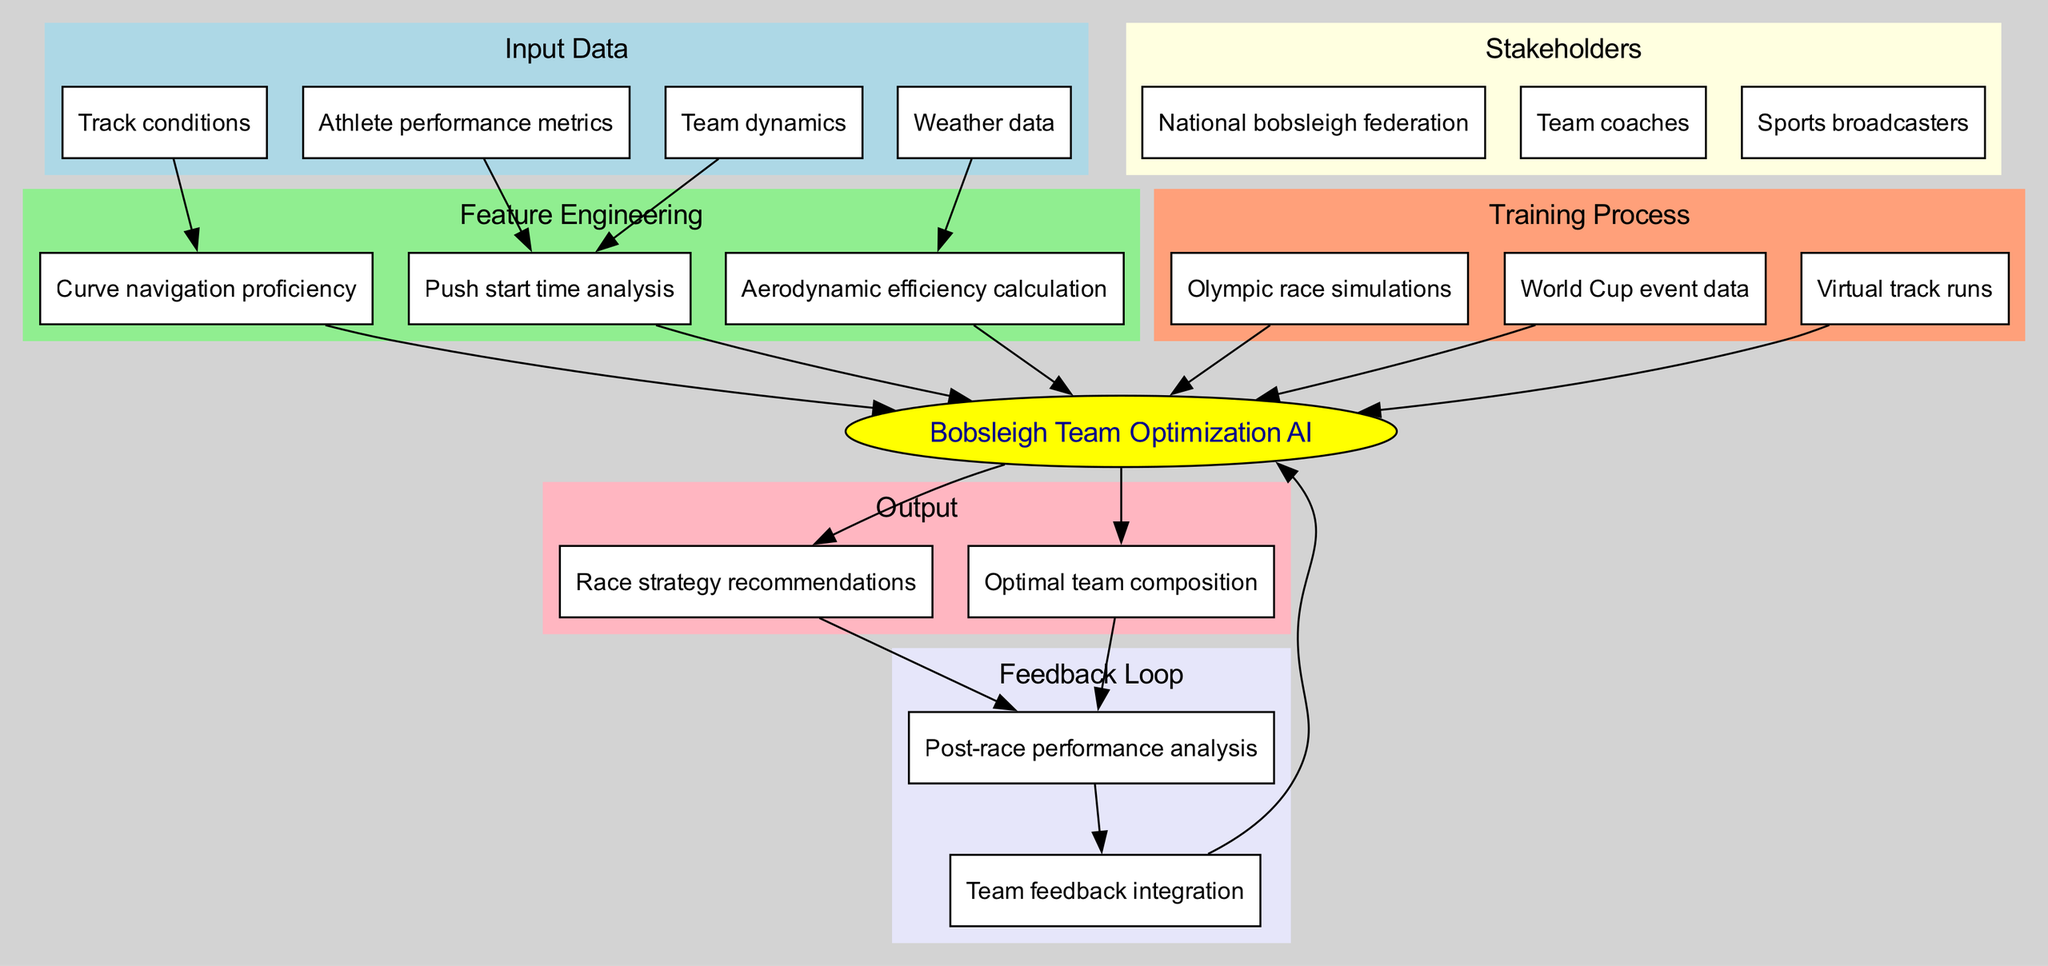What are the input data types in this diagram? The diagram lists four specific input data types: "Athlete performance metrics," "Track conditions," "Weather data," and "Team dynamics." These are located in the "Input Data" section at the top of the diagram.
Answer: Athlete performance metrics, Track conditions, Weather data, Team dynamics How many edges are connected to the "Bobsleigh Team Optimization AI" node? The "Bobsleigh Team Optimization AI" node has four edges connected to it: one from each of the "Feature Engineering" and "Training Process" sections, and two from the output nodes. This shows how inputs and processes directly link to the model's output.
Answer: Four Which feedback loop activity comes after the "Post-race performance analysis"? Following "Post-race performance analysis," the next activity in the feedback loop is "Team feedback integration." This can be traced by moving down from the analysis node.
Answer: Team feedback integration What are the output components of the model? The output components listed in the diagram are "Optimal team composition" and "Race strategy recommendations." Both these outputs are derived from the Bobsleigh model and are found in the "Output" section.
Answer: Optimal team composition, Race strategy recommendations How does "Weather data" influence the model? "Weather data" impacts the model by feeding into the "Aerodynamic efficiency calculation" feature engineering process, indicating that weather conditions are a factor in optimizing performance metrics for bobsleigh.
Answer: Aerodynamic efficiency calculation What is the significance of the "Training Process" section? The "Training Process" section provides essential simulation techniques and historical data used to train the model: "Olympic race simulations," "World Cup event data," and "Virtual track runs." This shows the methods used to refine the model's predictions and strategy.
Answer: Olympic race simulations, World Cup event data, Virtual track runs Who are the stakeholders identified in the diagram? The stakeholders identified are "National bobsleigh federation," "Team coaches," and "Sports broadcasters." These roles indicate the involved parties who utilize or influence the bobsleigh optimization strategies derived from the model.
Answer: National bobsleigh federation, Team coaches, Sports broadcasters What is represented in the "Feature Engineering" section? The "Feature Engineering" section includes three specific tasks: "Push start time analysis," "Aerodynamic efficiency calculation," and "Curve navigation proficiency." Each task contributes to refining the data input for model training and predictions.
Answer: Push start time analysis, Aerodynamic efficiency calculation, Curve navigation proficiency How is the optimization model self-improving? The optimization model incorporates a feedback loop that includes "Post-race performance analysis" and "Team feedback integration," allowing it to adapt and improve based on past performance and insights from the team.
Answer: Feedback loop 